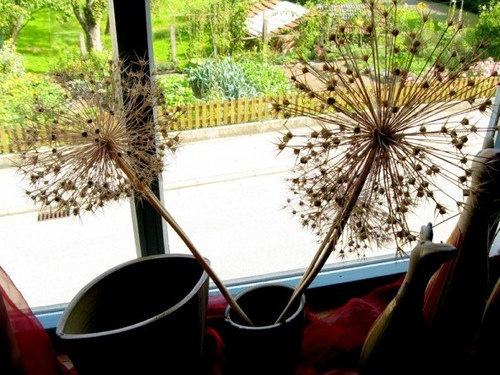Describe the objects in this image and their specific colors. I can see bowl in lightgreen, black, gray, darkgray, and white tones and vase in lightgreen, black, gray, and darkgray tones in this image. 